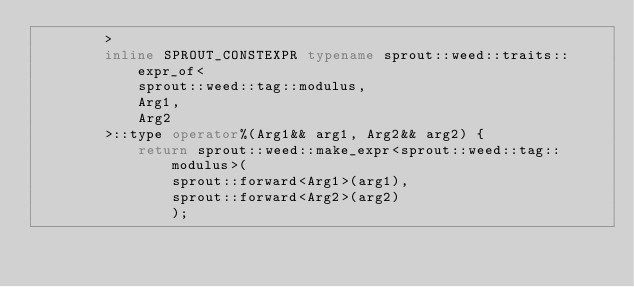<code> <loc_0><loc_0><loc_500><loc_500><_C++_>		>
		inline SPROUT_CONSTEXPR typename sprout::weed::traits::expr_of<
			sprout::weed::tag::modulus,
			Arg1,
			Arg2
		>::type operator%(Arg1&& arg1, Arg2&& arg2) {
			return sprout::weed::make_expr<sprout::weed::tag::modulus>(
				sprout::forward<Arg1>(arg1),
				sprout::forward<Arg2>(arg2)
				);</code> 